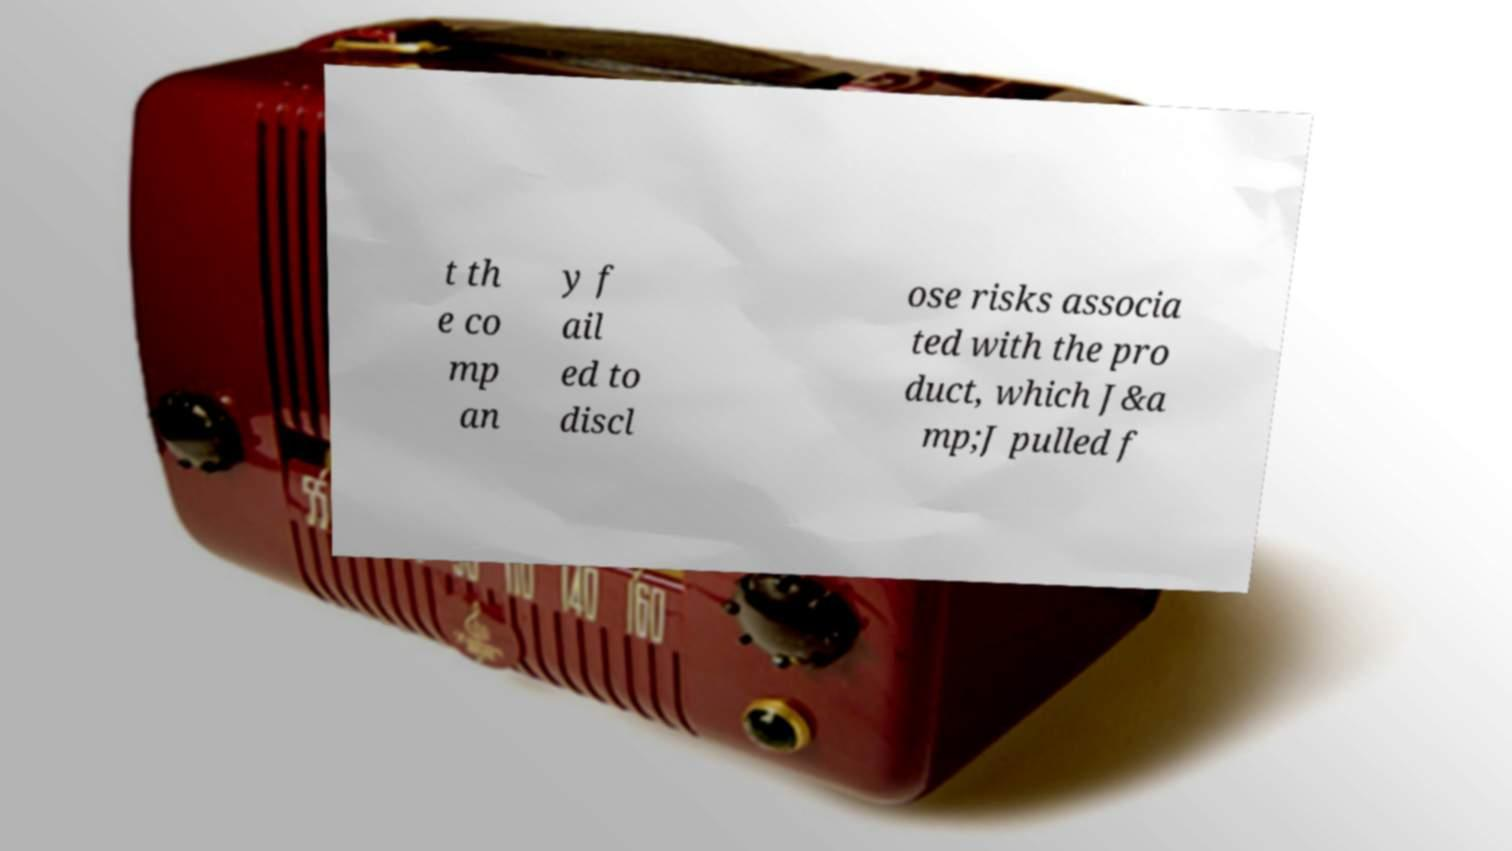Please identify and transcribe the text found in this image. t th e co mp an y f ail ed to discl ose risks associa ted with the pro duct, which J&a mp;J pulled f 